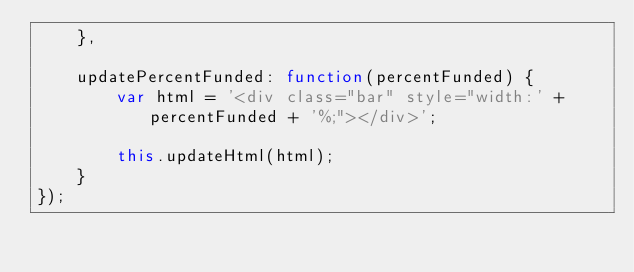<code> <loc_0><loc_0><loc_500><loc_500><_JavaScript_>    },

    updatePercentFunded: function(percentFunded) {
        var html = '<div class="bar" style="width:' + percentFunded + '%;"></div>';

        this.updateHtml(html);
    }
});</code> 